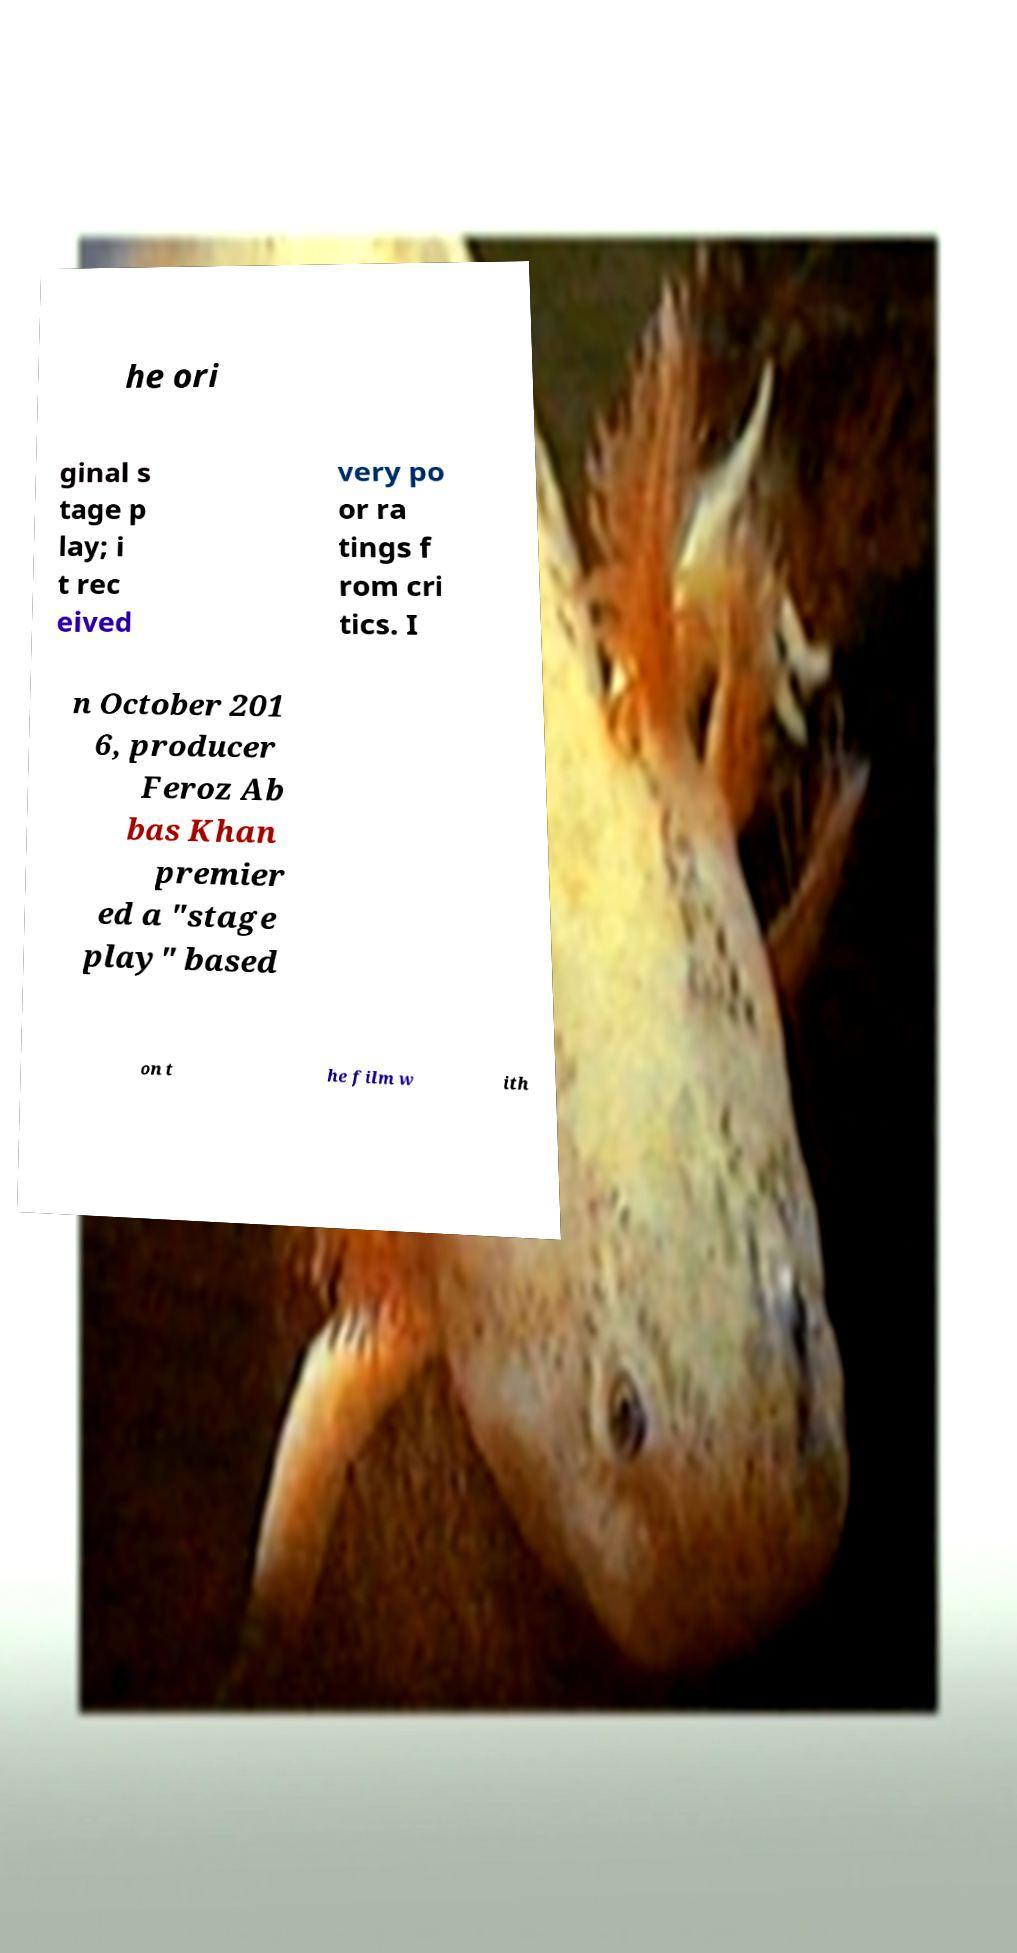Can you read and provide the text displayed in the image?This photo seems to have some interesting text. Can you extract and type it out for me? he ori ginal s tage p lay; i t rec eived very po or ra tings f rom cri tics. I n October 201 6, producer Feroz Ab bas Khan premier ed a "stage play" based on t he film w ith 